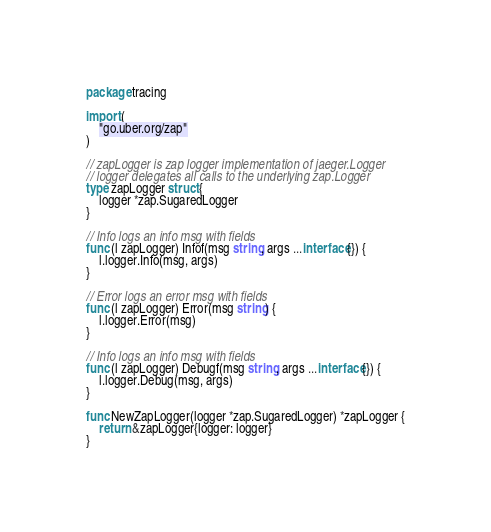<code> <loc_0><loc_0><loc_500><loc_500><_Go_>package tracing

import (
	"go.uber.org/zap"
)

// zapLogger is zap logger implementation of jaeger.Logger
// logger delegates all calls to the underlying zap.Logger
type zapLogger struct {
	logger *zap.SugaredLogger
}

// Info logs an info msg with fields
func (l zapLogger) Infof(msg string, args ...interface{}) {
	l.logger.Info(msg, args)
}

// Error logs an error msg with fields
func (l zapLogger) Error(msg string) {
	l.logger.Error(msg)
}

// Info logs an info msg with fields
func (l zapLogger) Debugf(msg string, args ...interface{}) {
	l.logger.Debug(msg, args)
}

func NewZapLogger(logger *zap.SugaredLogger) *zapLogger {
	return &zapLogger{logger: logger}
}
</code> 